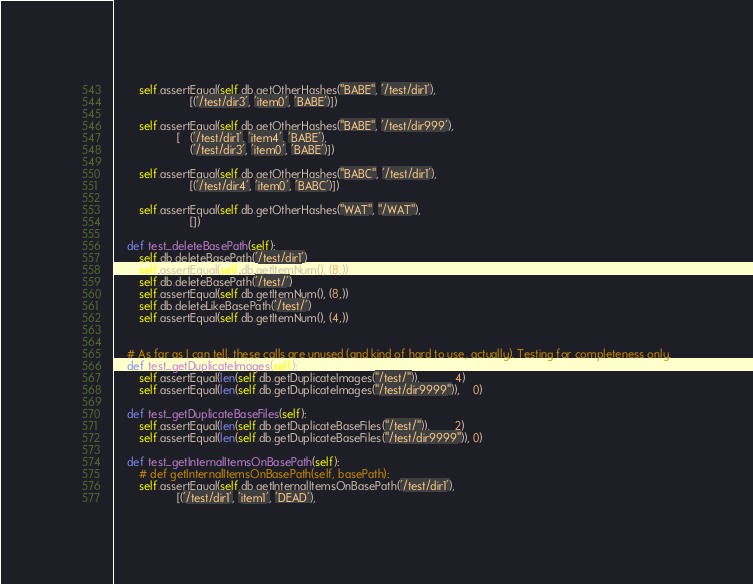Convert code to text. <code><loc_0><loc_0><loc_500><loc_500><_Python_>		self.assertEqual(self.db.getOtherHashes("BABE", '/test/dir1'),
						[('/test/dir3', 'item0', 'BABE')])

		self.assertEqual(self.db.getOtherHashes("BABE", '/test/dir999'),
					[   ('/test/dir1', 'item4', 'BABE'),
						('/test/dir3', 'item0', 'BABE')])

		self.assertEqual(self.db.getOtherHashes("BABC", '/test/dir1'),
						[('/test/dir4', 'item0', 'BABC')])

		self.assertEqual(self.db.getOtherHashes("WAT", "/WAT"),
						[])

	def test_deleteBasePath(self):
		self.db.deleteBasePath('/test/dir1')
		self.assertEqual(self.db.getItemNum(), (8,))
		self.db.deleteBasePath('/test/')
		self.assertEqual(self.db.getItemNum(), (8,))
		self.db.deleteLikeBasePath('/test/')
		self.assertEqual(self.db.getItemNum(), (4,))


	# As far as I can tell, these calls are unused (and kind of hard to use, actually). Testing for completeness only.
	def test_getDuplicateImages(self):
		self.assertEqual(len(self.db.getDuplicateImages("/test/")),           4)
		self.assertEqual(len(self.db.getDuplicateImages("/test/dir9999")),    0)

	def test_getDuplicateBaseFiles(self):
		self.assertEqual(len(self.db.getDuplicateBaseFiles("/test/")),        2)
		self.assertEqual(len(self.db.getDuplicateBaseFiles("/test/dir9999")), 0)

	def test_getInternalItemsOnBasePath(self):
		# def getInternalItemsOnBasePath(self, basePath):
		self.assertEqual(self.db.getInternalItemsOnBasePath('/test/dir1'),
					[('/test/dir1', 'item1', 'DEAD'),</code> 